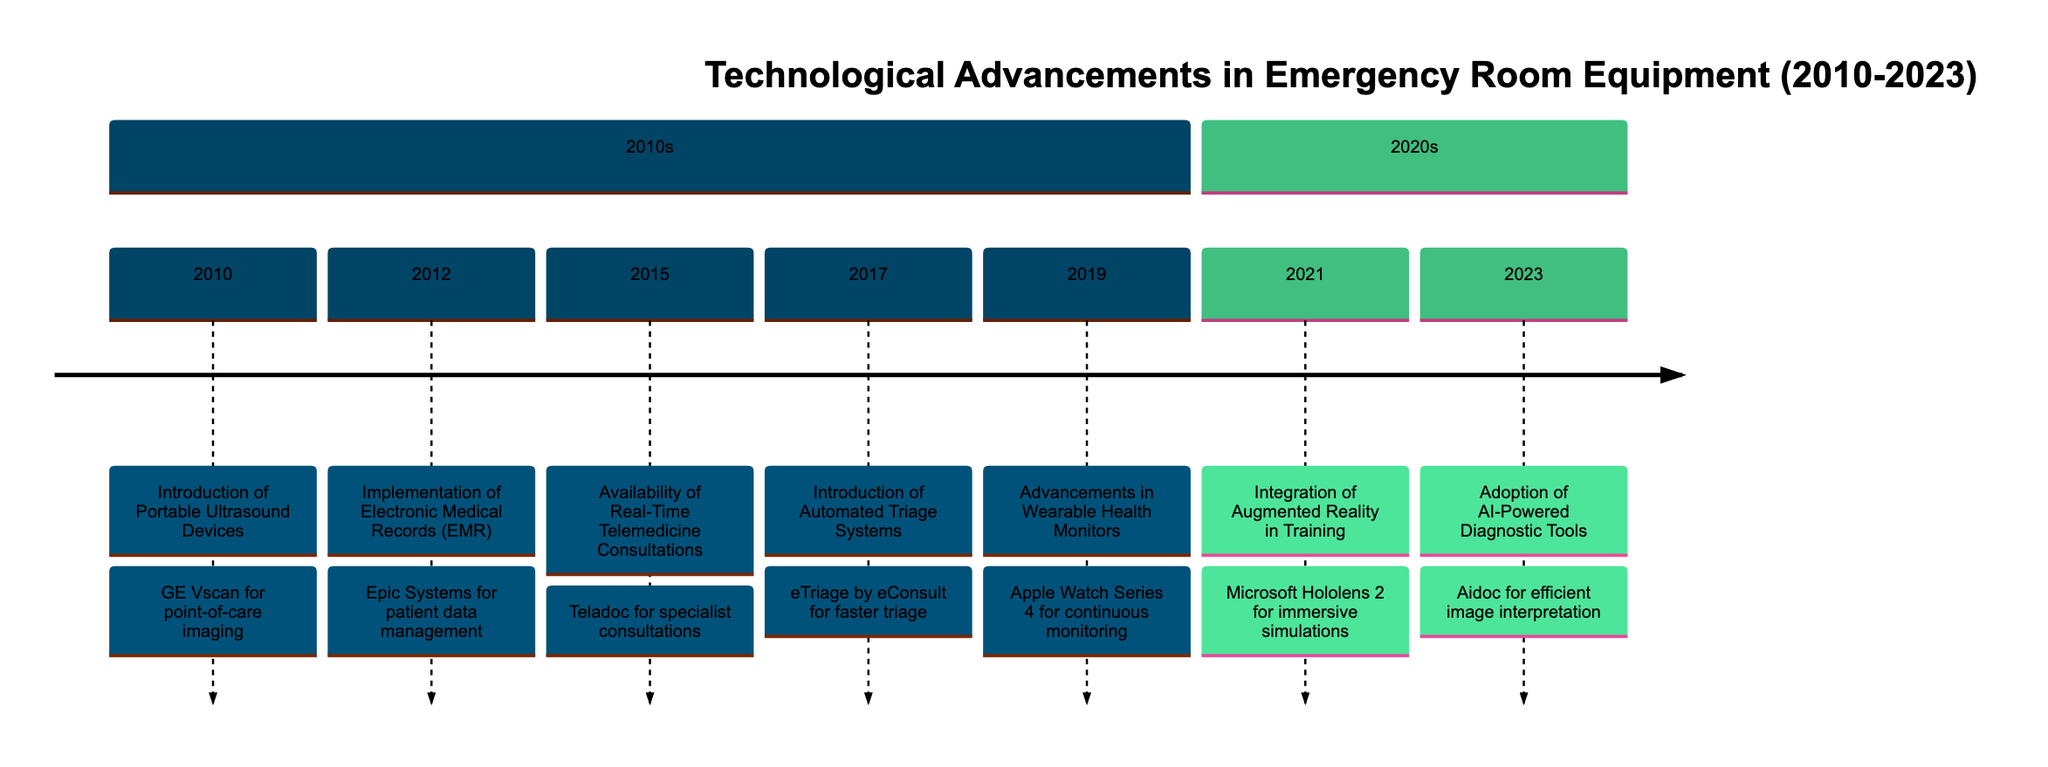What was the first technological advancement in the timeline? The first advancement listed is from 2010, which is the "Introduction of Portable Ultrasound Devices." This is found at the beginning of the timeline.
Answer: Introduction of Portable Ultrasound Devices How many technological advancements occurred in the 2010s? Counting the listed advancements in the 2010s section shows there are five advancements: 2010, 2012, 2015, 2017, and 2019.
Answer: 5 What advancement took place in 2019? Referring to the year 2019 in the timeline, the advancement is "Advancements in Wearable Health Monitors," outlined in that specific year.
Answer: Advancements in Wearable Health Monitors Which technological advancement was associated with 2021? Looking at the year 2021, the advancement noted is "Integration of Augmented Reality in Training." This is in the 2020s section of the timeline.
Answer: Integration of Augmented Reality in Training What is the last advancement in the timeline? The last year listed is 2023, where the advancement mentioned is "Adoption of AI-Powered Diagnostic Tools." This indicates it is the final entry in the timeline.
Answer: Adoption of AI-Powered Diagnostic Tools Which device was introduced for point-of-care imaging in 2010? The diagram indicates that in 2010, the device introduced was the "GE Vscan," which is explicitly mentioned along with its function.
Answer: GE Vscan What is the main purpose of the Automated Triage Systems introduced in 2017? The timeline describes the function of Automated Triage Systems as facilitating "faster and more accurate triage of patients," which suggests their key role in patient management.
Answer: Faster and more accurate triage What technological advancement improved patient data management? The 2012 advancement, "Implementation of Electronic Medical Records (EMR)," notably improved patient data management according to the description.
Answer: Implementation of Electronic Medical Records (EMR) What was the primary function of the wearable health monitors introduced in 2019? The timeline describes the wearable health monitors as providing "continuous patient monitoring data," which helps track vital signs.
Answer: Continuous patient monitoring data 